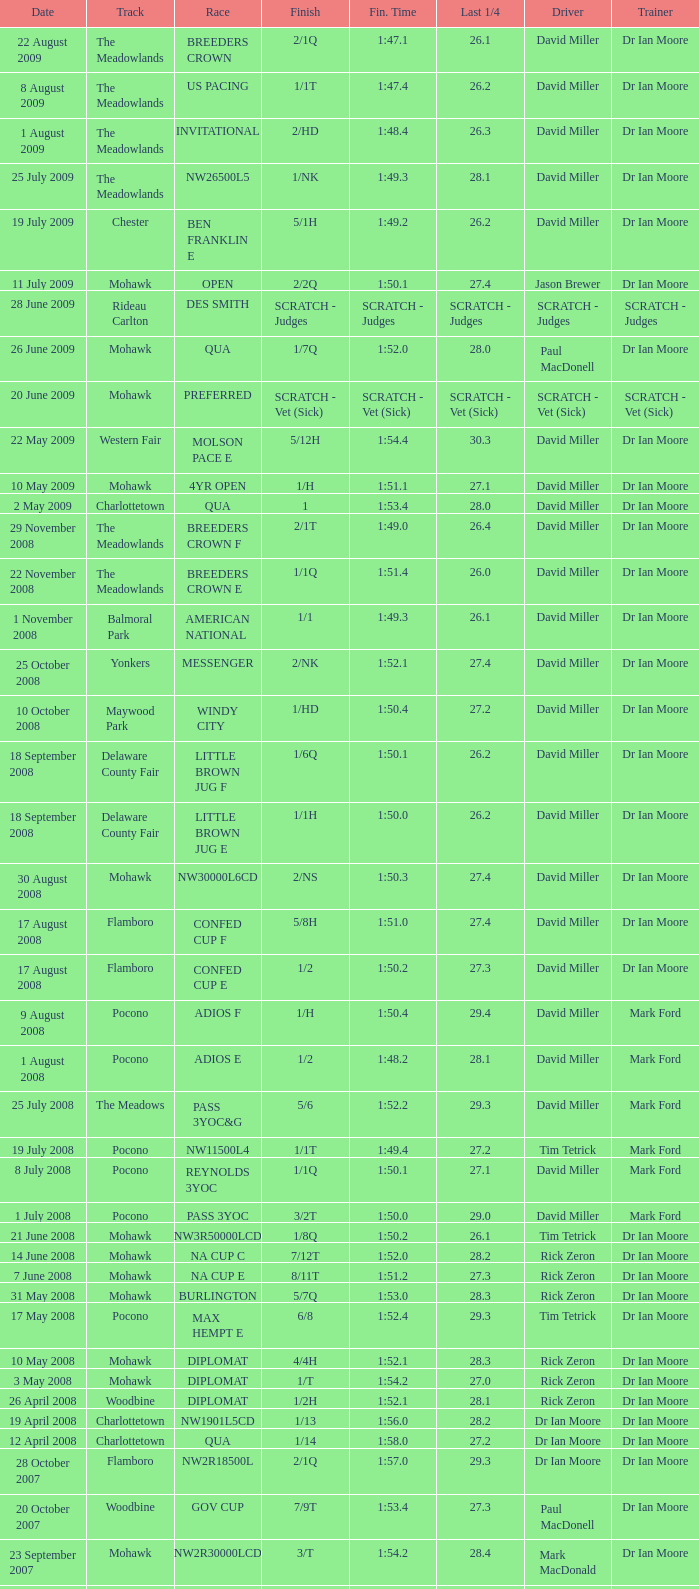What is the finishing time with a 2/1q finish on the Meadowlands track? 1:47.1. 